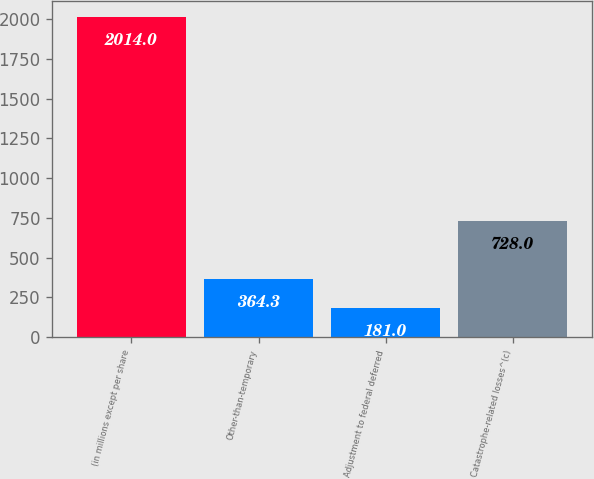<chart> <loc_0><loc_0><loc_500><loc_500><bar_chart><fcel>(in millions except per share<fcel>Other-than-temporary<fcel>Adjustment to federal deferred<fcel>Catastrophe-related losses^(c)<nl><fcel>2014<fcel>364.3<fcel>181<fcel>728<nl></chart> 